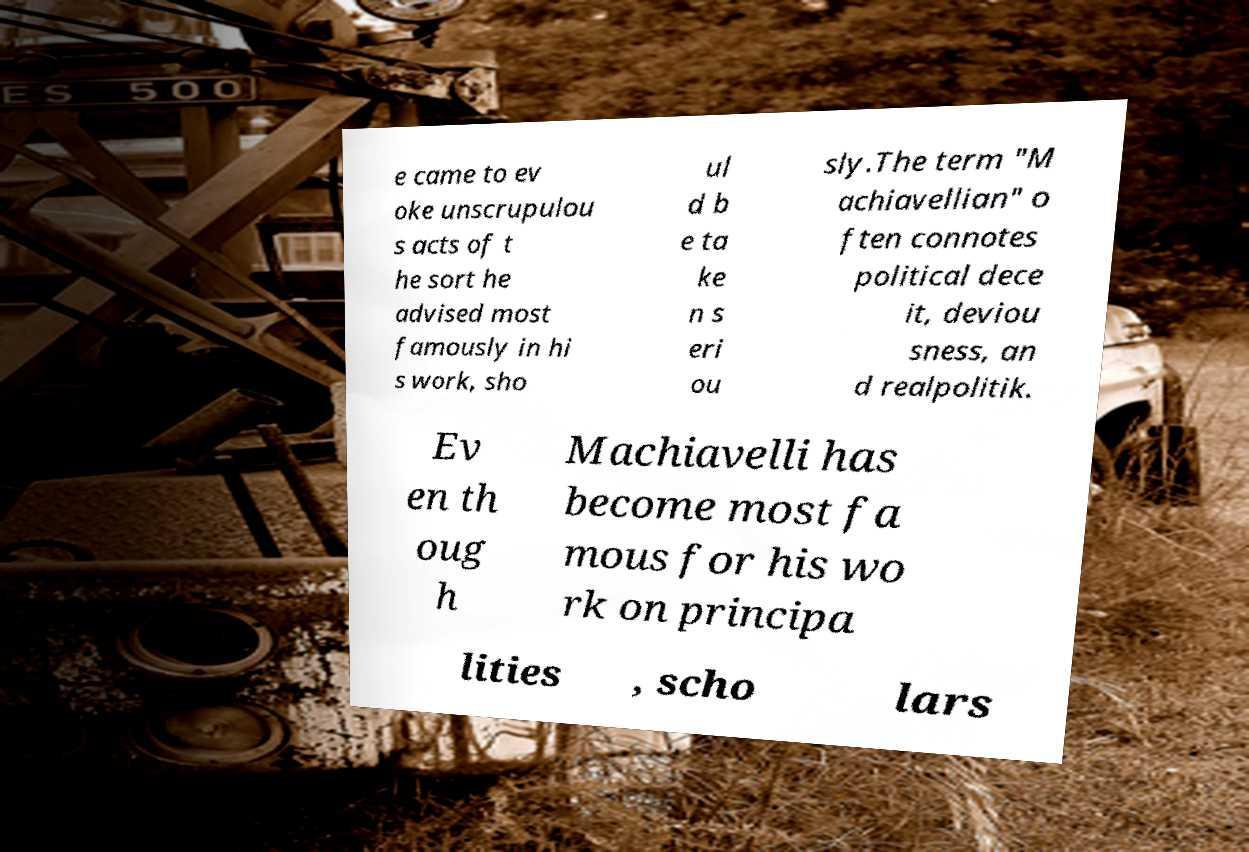Please read and relay the text visible in this image. What does it say? e came to ev oke unscrupulou s acts of t he sort he advised most famously in hi s work, sho ul d b e ta ke n s eri ou sly.The term "M achiavellian" o ften connotes political dece it, deviou sness, an d realpolitik. Ev en th oug h Machiavelli has become most fa mous for his wo rk on principa lities , scho lars 